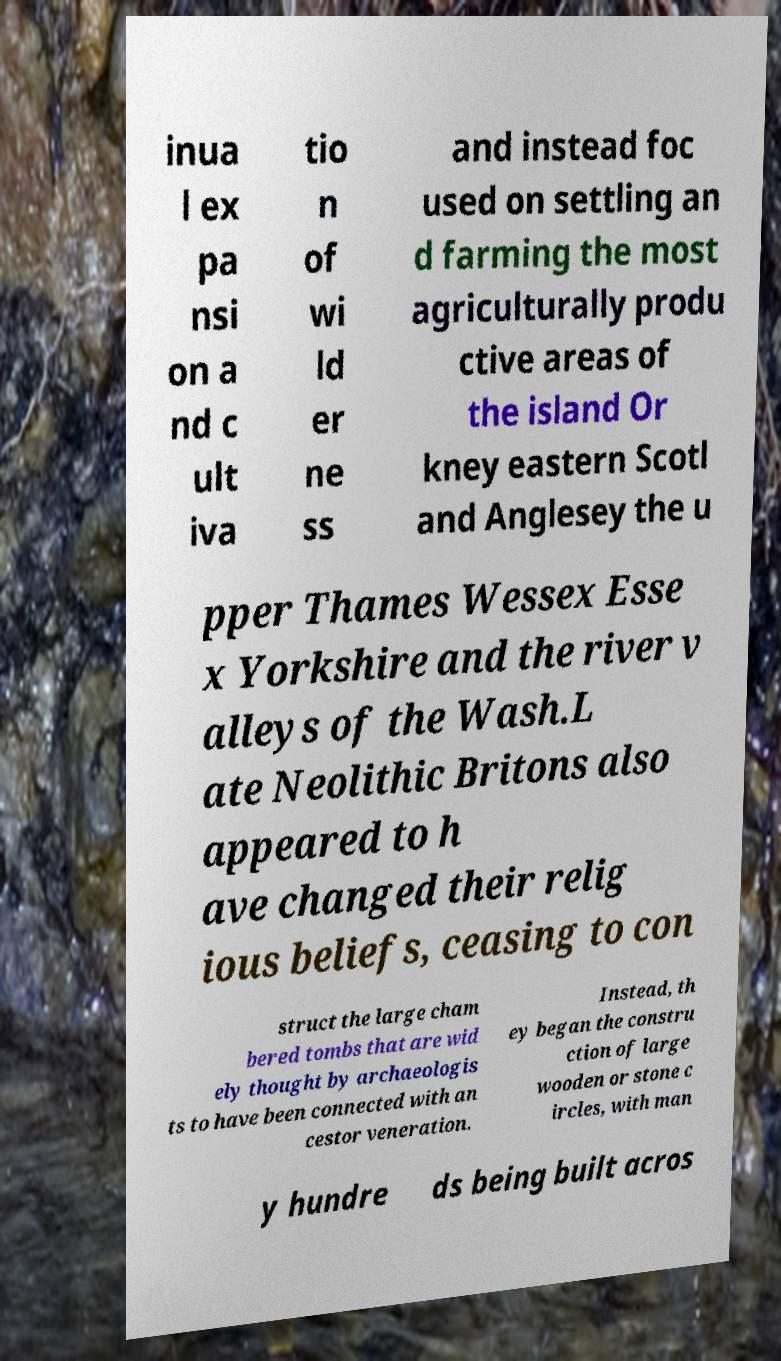For documentation purposes, I need the text within this image transcribed. Could you provide that? inua l ex pa nsi on a nd c ult iva tio n of wi ld er ne ss and instead foc used on settling an d farming the most agriculturally produ ctive areas of the island Or kney eastern Scotl and Anglesey the u pper Thames Wessex Esse x Yorkshire and the river v alleys of the Wash.L ate Neolithic Britons also appeared to h ave changed their relig ious beliefs, ceasing to con struct the large cham bered tombs that are wid ely thought by archaeologis ts to have been connected with an cestor veneration. Instead, th ey began the constru ction of large wooden or stone c ircles, with man y hundre ds being built acros 